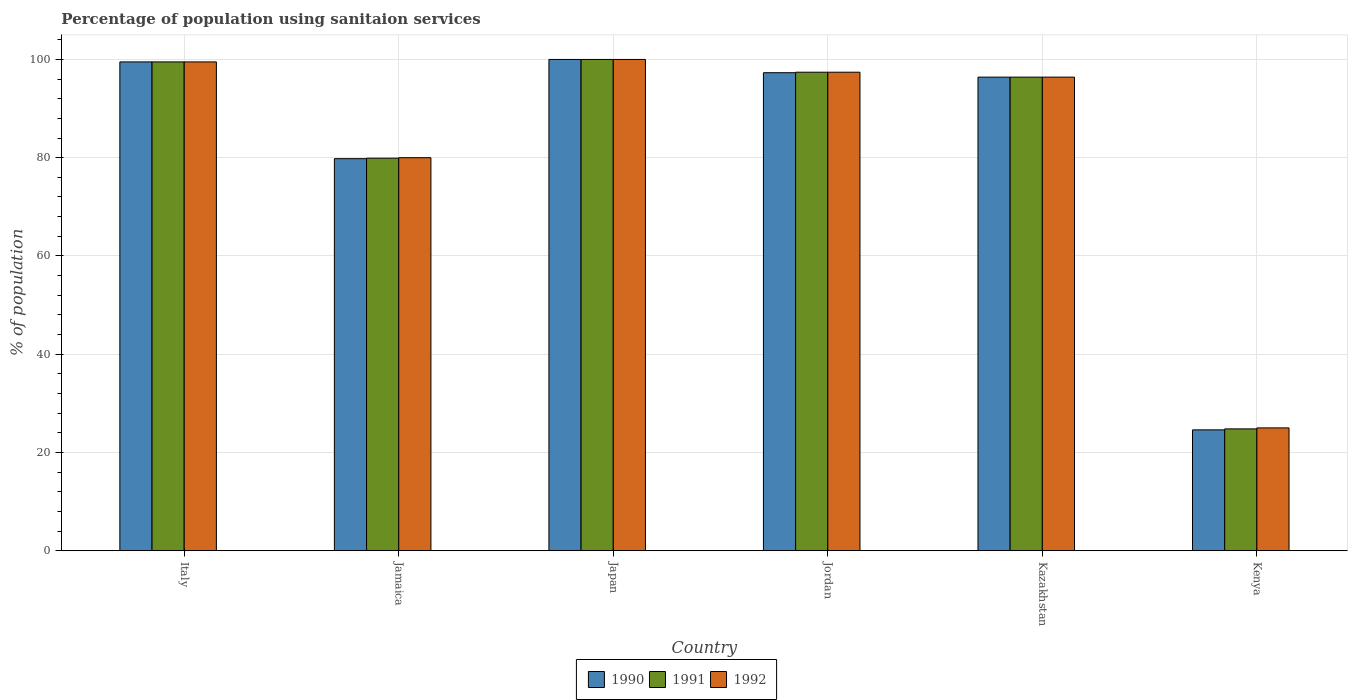How many groups of bars are there?
Make the answer very short. 6. Are the number of bars on each tick of the X-axis equal?
Your response must be concise. Yes. What is the label of the 1st group of bars from the left?
Your response must be concise. Italy. What is the percentage of population using sanitaion services in 1992 in Italy?
Your response must be concise. 99.5. Across all countries, what is the minimum percentage of population using sanitaion services in 1990?
Offer a very short reply. 24.6. In which country was the percentage of population using sanitaion services in 1991 maximum?
Your response must be concise. Japan. In which country was the percentage of population using sanitaion services in 1992 minimum?
Provide a succinct answer. Kenya. What is the total percentage of population using sanitaion services in 1991 in the graph?
Keep it short and to the point. 498. What is the difference between the percentage of population using sanitaion services in 1990 in Japan and that in Kenya?
Provide a short and direct response. 75.4. What is the difference between the percentage of population using sanitaion services in 1992 in Jamaica and the percentage of population using sanitaion services in 1991 in Kazakhstan?
Provide a succinct answer. -16.4. What is the average percentage of population using sanitaion services in 1991 per country?
Keep it short and to the point. 83. What is the ratio of the percentage of population using sanitaion services in 1992 in Italy to that in Jamaica?
Offer a very short reply. 1.24. Is the percentage of population using sanitaion services in 1992 in Japan less than that in Jordan?
Offer a very short reply. No. Is the difference between the percentage of population using sanitaion services in 1992 in Japan and Kazakhstan greater than the difference between the percentage of population using sanitaion services in 1991 in Japan and Kazakhstan?
Keep it short and to the point. No. What is the difference between the highest and the second highest percentage of population using sanitaion services in 1992?
Your answer should be very brief. -2.1. What is the difference between the highest and the lowest percentage of population using sanitaion services in 1990?
Make the answer very short. 75.4. In how many countries, is the percentage of population using sanitaion services in 1990 greater than the average percentage of population using sanitaion services in 1990 taken over all countries?
Keep it short and to the point. 4. Is the sum of the percentage of population using sanitaion services in 1992 in Kazakhstan and Kenya greater than the maximum percentage of population using sanitaion services in 1990 across all countries?
Make the answer very short. Yes. What does the 2nd bar from the left in Kazakhstan represents?
Keep it short and to the point. 1991. Is it the case that in every country, the sum of the percentage of population using sanitaion services in 1992 and percentage of population using sanitaion services in 1991 is greater than the percentage of population using sanitaion services in 1990?
Keep it short and to the point. Yes. How many bars are there?
Your answer should be compact. 18. How many countries are there in the graph?
Provide a short and direct response. 6. Does the graph contain any zero values?
Your answer should be very brief. No. How many legend labels are there?
Ensure brevity in your answer.  3. What is the title of the graph?
Your answer should be compact. Percentage of population using sanitaion services. Does "1970" appear as one of the legend labels in the graph?
Offer a terse response. No. What is the label or title of the Y-axis?
Give a very brief answer. % of population. What is the % of population in 1990 in Italy?
Give a very brief answer. 99.5. What is the % of population of 1991 in Italy?
Make the answer very short. 99.5. What is the % of population of 1992 in Italy?
Give a very brief answer. 99.5. What is the % of population of 1990 in Jamaica?
Make the answer very short. 79.8. What is the % of population of 1991 in Jamaica?
Offer a terse response. 79.9. What is the % of population of 1992 in Jamaica?
Ensure brevity in your answer.  80. What is the % of population in 1990 in Japan?
Make the answer very short. 100. What is the % of population of 1991 in Japan?
Your answer should be compact. 100. What is the % of population of 1990 in Jordan?
Your answer should be very brief. 97.3. What is the % of population of 1991 in Jordan?
Offer a terse response. 97.4. What is the % of population in 1992 in Jordan?
Provide a succinct answer. 97.4. What is the % of population in 1990 in Kazakhstan?
Offer a terse response. 96.4. What is the % of population of 1991 in Kazakhstan?
Give a very brief answer. 96.4. What is the % of population in 1992 in Kazakhstan?
Offer a terse response. 96.4. What is the % of population of 1990 in Kenya?
Provide a short and direct response. 24.6. What is the % of population of 1991 in Kenya?
Offer a very short reply. 24.8. What is the % of population of 1992 in Kenya?
Offer a terse response. 25. Across all countries, what is the minimum % of population of 1990?
Provide a succinct answer. 24.6. Across all countries, what is the minimum % of population in 1991?
Offer a terse response. 24.8. What is the total % of population in 1990 in the graph?
Give a very brief answer. 497.6. What is the total % of population in 1991 in the graph?
Give a very brief answer. 498. What is the total % of population in 1992 in the graph?
Offer a terse response. 498.3. What is the difference between the % of population of 1990 in Italy and that in Jamaica?
Your answer should be compact. 19.7. What is the difference between the % of population in 1991 in Italy and that in Jamaica?
Your answer should be compact. 19.6. What is the difference between the % of population of 1992 in Italy and that in Jamaica?
Offer a very short reply. 19.5. What is the difference between the % of population in 1992 in Italy and that in Japan?
Make the answer very short. -0.5. What is the difference between the % of population of 1991 in Italy and that in Jordan?
Keep it short and to the point. 2.1. What is the difference between the % of population in 1992 in Italy and that in Jordan?
Give a very brief answer. 2.1. What is the difference between the % of population in 1990 in Italy and that in Kazakhstan?
Provide a succinct answer. 3.1. What is the difference between the % of population in 1991 in Italy and that in Kazakhstan?
Offer a very short reply. 3.1. What is the difference between the % of population of 1992 in Italy and that in Kazakhstan?
Keep it short and to the point. 3.1. What is the difference between the % of population in 1990 in Italy and that in Kenya?
Your answer should be very brief. 74.9. What is the difference between the % of population in 1991 in Italy and that in Kenya?
Give a very brief answer. 74.7. What is the difference between the % of population in 1992 in Italy and that in Kenya?
Offer a terse response. 74.5. What is the difference between the % of population in 1990 in Jamaica and that in Japan?
Your answer should be compact. -20.2. What is the difference between the % of population of 1991 in Jamaica and that in Japan?
Offer a terse response. -20.1. What is the difference between the % of population of 1990 in Jamaica and that in Jordan?
Offer a very short reply. -17.5. What is the difference between the % of population in 1991 in Jamaica and that in Jordan?
Your response must be concise. -17.5. What is the difference between the % of population of 1992 in Jamaica and that in Jordan?
Give a very brief answer. -17.4. What is the difference between the % of population of 1990 in Jamaica and that in Kazakhstan?
Make the answer very short. -16.6. What is the difference between the % of population of 1991 in Jamaica and that in Kazakhstan?
Give a very brief answer. -16.5. What is the difference between the % of population of 1992 in Jamaica and that in Kazakhstan?
Your response must be concise. -16.4. What is the difference between the % of population in 1990 in Jamaica and that in Kenya?
Ensure brevity in your answer.  55.2. What is the difference between the % of population of 1991 in Jamaica and that in Kenya?
Your response must be concise. 55.1. What is the difference between the % of population of 1992 in Jamaica and that in Kenya?
Offer a very short reply. 55. What is the difference between the % of population in 1990 in Japan and that in Jordan?
Your response must be concise. 2.7. What is the difference between the % of population in 1992 in Japan and that in Kazakhstan?
Offer a very short reply. 3.6. What is the difference between the % of population in 1990 in Japan and that in Kenya?
Keep it short and to the point. 75.4. What is the difference between the % of population of 1991 in Japan and that in Kenya?
Your response must be concise. 75.2. What is the difference between the % of population in 1990 in Jordan and that in Kenya?
Keep it short and to the point. 72.7. What is the difference between the % of population in 1991 in Jordan and that in Kenya?
Offer a very short reply. 72.6. What is the difference between the % of population in 1992 in Jordan and that in Kenya?
Provide a short and direct response. 72.4. What is the difference between the % of population in 1990 in Kazakhstan and that in Kenya?
Offer a terse response. 71.8. What is the difference between the % of population in 1991 in Kazakhstan and that in Kenya?
Make the answer very short. 71.6. What is the difference between the % of population of 1992 in Kazakhstan and that in Kenya?
Ensure brevity in your answer.  71.4. What is the difference between the % of population in 1990 in Italy and the % of population in 1991 in Jamaica?
Make the answer very short. 19.6. What is the difference between the % of population of 1990 in Italy and the % of population of 1992 in Jamaica?
Provide a short and direct response. 19.5. What is the difference between the % of population in 1990 in Italy and the % of population in 1991 in Japan?
Provide a succinct answer. -0.5. What is the difference between the % of population of 1990 in Italy and the % of population of 1991 in Jordan?
Keep it short and to the point. 2.1. What is the difference between the % of population of 1991 in Italy and the % of population of 1992 in Jordan?
Your response must be concise. 2.1. What is the difference between the % of population of 1990 in Italy and the % of population of 1991 in Kazakhstan?
Offer a very short reply. 3.1. What is the difference between the % of population in 1990 in Italy and the % of population in 1992 in Kazakhstan?
Your answer should be compact. 3.1. What is the difference between the % of population in 1990 in Italy and the % of population in 1991 in Kenya?
Provide a short and direct response. 74.7. What is the difference between the % of population of 1990 in Italy and the % of population of 1992 in Kenya?
Provide a succinct answer. 74.5. What is the difference between the % of population of 1991 in Italy and the % of population of 1992 in Kenya?
Offer a terse response. 74.5. What is the difference between the % of population in 1990 in Jamaica and the % of population in 1991 in Japan?
Make the answer very short. -20.2. What is the difference between the % of population in 1990 in Jamaica and the % of population in 1992 in Japan?
Make the answer very short. -20.2. What is the difference between the % of population of 1991 in Jamaica and the % of population of 1992 in Japan?
Provide a short and direct response. -20.1. What is the difference between the % of population in 1990 in Jamaica and the % of population in 1991 in Jordan?
Offer a very short reply. -17.6. What is the difference between the % of population of 1990 in Jamaica and the % of population of 1992 in Jordan?
Give a very brief answer. -17.6. What is the difference between the % of population of 1991 in Jamaica and the % of population of 1992 in Jordan?
Ensure brevity in your answer.  -17.5. What is the difference between the % of population in 1990 in Jamaica and the % of population in 1991 in Kazakhstan?
Give a very brief answer. -16.6. What is the difference between the % of population of 1990 in Jamaica and the % of population of 1992 in Kazakhstan?
Make the answer very short. -16.6. What is the difference between the % of population in 1991 in Jamaica and the % of population in 1992 in Kazakhstan?
Keep it short and to the point. -16.5. What is the difference between the % of population in 1990 in Jamaica and the % of population in 1991 in Kenya?
Your response must be concise. 55. What is the difference between the % of population of 1990 in Jamaica and the % of population of 1992 in Kenya?
Provide a short and direct response. 54.8. What is the difference between the % of population in 1991 in Jamaica and the % of population in 1992 in Kenya?
Offer a very short reply. 54.9. What is the difference between the % of population in 1990 in Japan and the % of population in 1991 in Jordan?
Your answer should be compact. 2.6. What is the difference between the % of population in 1990 in Japan and the % of population in 1991 in Kazakhstan?
Provide a succinct answer. 3.6. What is the difference between the % of population of 1990 in Japan and the % of population of 1991 in Kenya?
Keep it short and to the point. 75.2. What is the difference between the % of population in 1990 in Japan and the % of population in 1992 in Kenya?
Offer a very short reply. 75. What is the difference between the % of population in 1991 in Japan and the % of population in 1992 in Kenya?
Your answer should be compact. 75. What is the difference between the % of population in 1990 in Jordan and the % of population in 1992 in Kazakhstan?
Offer a very short reply. 0.9. What is the difference between the % of population of 1990 in Jordan and the % of population of 1991 in Kenya?
Give a very brief answer. 72.5. What is the difference between the % of population in 1990 in Jordan and the % of population in 1992 in Kenya?
Ensure brevity in your answer.  72.3. What is the difference between the % of population in 1991 in Jordan and the % of population in 1992 in Kenya?
Provide a succinct answer. 72.4. What is the difference between the % of population in 1990 in Kazakhstan and the % of population in 1991 in Kenya?
Your answer should be compact. 71.6. What is the difference between the % of population of 1990 in Kazakhstan and the % of population of 1992 in Kenya?
Your answer should be very brief. 71.4. What is the difference between the % of population of 1991 in Kazakhstan and the % of population of 1992 in Kenya?
Make the answer very short. 71.4. What is the average % of population of 1990 per country?
Your answer should be very brief. 82.93. What is the average % of population in 1992 per country?
Make the answer very short. 83.05. What is the difference between the % of population of 1991 and % of population of 1992 in Japan?
Make the answer very short. 0. What is the difference between the % of population of 1990 and % of population of 1991 in Kazakhstan?
Make the answer very short. 0. What is the difference between the % of population in 1990 and % of population in 1992 in Kazakhstan?
Provide a short and direct response. 0. What is the difference between the % of population in 1991 and % of population in 1992 in Kazakhstan?
Your response must be concise. 0. What is the difference between the % of population of 1990 and % of population of 1991 in Kenya?
Keep it short and to the point. -0.2. What is the difference between the % of population in 1990 and % of population in 1992 in Kenya?
Provide a succinct answer. -0.4. What is the ratio of the % of population in 1990 in Italy to that in Jamaica?
Give a very brief answer. 1.25. What is the ratio of the % of population of 1991 in Italy to that in Jamaica?
Keep it short and to the point. 1.25. What is the ratio of the % of population of 1992 in Italy to that in Jamaica?
Your answer should be compact. 1.24. What is the ratio of the % of population in 1990 in Italy to that in Japan?
Offer a very short reply. 0.99. What is the ratio of the % of population of 1992 in Italy to that in Japan?
Ensure brevity in your answer.  0.99. What is the ratio of the % of population of 1990 in Italy to that in Jordan?
Keep it short and to the point. 1.02. What is the ratio of the % of population in 1991 in Italy to that in Jordan?
Your answer should be very brief. 1.02. What is the ratio of the % of population in 1992 in Italy to that in Jordan?
Your answer should be very brief. 1.02. What is the ratio of the % of population in 1990 in Italy to that in Kazakhstan?
Keep it short and to the point. 1.03. What is the ratio of the % of population in 1991 in Italy to that in Kazakhstan?
Offer a very short reply. 1.03. What is the ratio of the % of population of 1992 in Italy to that in Kazakhstan?
Your answer should be very brief. 1.03. What is the ratio of the % of population of 1990 in Italy to that in Kenya?
Your answer should be very brief. 4.04. What is the ratio of the % of population of 1991 in Italy to that in Kenya?
Keep it short and to the point. 4.01. What is the ratio of the % of population of 1992 in Italy to that in Kenya?
Provide a succinct answer. 3.98. What is the ratio of the % of population of 1990 in Jamaica to that in Japan?
Make the answer very short. 0.8. What is the ratio of the % of population in 1991 in Jamaica to that in Japan?
Provide a short and direct response. 0.8. What is the ratio of the % of population of 1992 in Jamaica to that in Japan?
Ensure brevity in your answer.  0.8. What is the ratio of the % of population of 1990 in Jamaica to that in Jordan?
Give a very brief answer. 0.82. What is the ratio of the % of population in 1991 in Jamaica to that in Jordan?
Ensure brevity in your answer.  0.82. What is the ratio of the % of population in 1992 in Jamaica to that in Jordan?
Your answer should be very brief. 0.82. What is the ratio of the % of population in 1990 in Jamaica to that in Kazakhstan?
Your response must be concise. 0.83. What is the ratio of the % of population of 1991 in Jamaica to that in Kazakhstan?
Offer a terse response. 0.83. What is the ratio of the % of population in 1992 in Jamaica to that in Kazakhstan?
Ensure brevity in your answer.  0.83. What is the ratio of the % of population in 1990 in Jamaica to that in Kenya?
Offer a very short reply. 3.24. What is the ratio of the % of population in 1991 in Jamaica to that in Kenya?
Ensure brevity in your answer.  3.22. What is the ratio of the % of population in 1992 in Jamaica to that in Kenya?
Provide a short and direct response. 3.2. What is the ratio of the % of population of 1990 in Japan to that in Jordan?
Offer a terse response. 1.03. What is the ratio of the % of population in 1991 in Japan to that in Jordan?
Provide a succinct answer. 1.03. What is the ratio of the % of population in 1992 in Japan to that in Jordan?
Your answer should be very brief. 1.03. What is the ratio of the % of population in 1990 in Japan to that in Kazakhstan?
Your answer should be very brief. 1.04. What is the ratio of the % of population of 1991 in Japan to that in Kazakhstan?
Provide a succinct answer. 1.04. What is the ratio of the % of population in 1992 in Japan to that in Kazakhstan?
Make the answer very short. 1.04. What is the ratio of the % of population of 1990 in Japan to that in Kenya?
Provide a short and direct response. 4.07. What is the ratio of the % of population in 1991 in Japan to that in Kenya?
Provide a succinct answer. 4.03. What is the ratio of the % of population of 1990 in Jordan to that in Kazakhstan?
Ensure brevity in your answer.  1.01. What is the ratio of the % of population of 1991 in Jordan to that in Kazakhstan?
Offer a very short reply. 1.01. What is the ratio of the % of population in 1992 in Jordan to that in Kazakhstan?
Provide a short and direct response. 1.01. What is the ratio of the % of population of 1990 in Jordan to that in Kenya?
Offer a very short reply. 3.96. What is the ratio of the % of population in 1991 in Jordan to that in Kenya?
Provide a succinct answer. 3.93. What is the ratio of the % of population in 1992 in Jordan to that in Kenya?
Give a very brief answer. 3.9. What is the ratio of the % of population of 1990 in Kazakhstan to that in Kenya?
Offer a terse response. 3.92. What is the ratio of the % of population in 1991 in Kazakhstan to that in Kenya?
Provide a short and direct response. 3.89. What is the ratio of the % of population of 1992 in Kazakhstan to that in Kenya?
Keep it short and to the point. 3.86. What is the difference between the highest and the second highest % of population of 1990?
Make the answer very short. 0.5. What is the difference between the highest and the lowest % of population in 1990?
Keep it short and to the point. 75.4. What is the difference between the highest and the lowest % of population in 1991?
Your response must be concise. 75.2. What is the difference between the highest and the lowest % of population in 1992?
Keep it short and to the point. 75. 